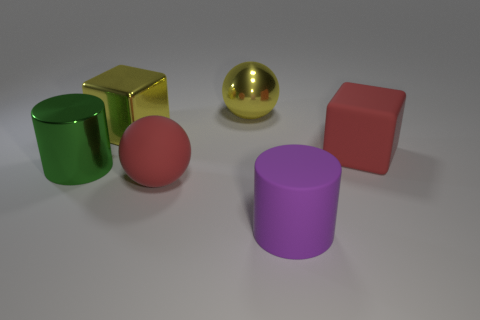What is the color of the other object that is the same shape as the large green object? purple 